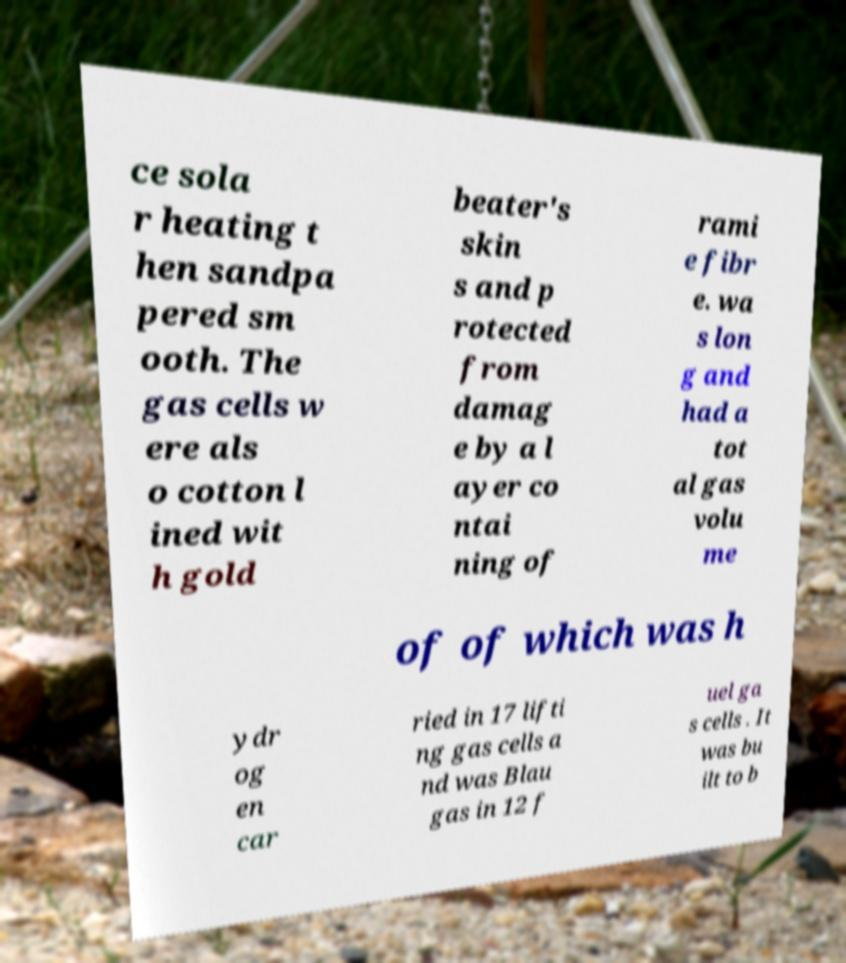I need the written content from this picture converted into text. Can you do that? ce sola r heating t hen sandpa pered sm ooth. The gas cells w ere als o cotton l ined wit h gold beater's skin s and p rotected from damag e by a l ayer co ntai ning of rami e fibr e. wa s lon g and had a tot al gas volu me of of which was h ydr og en car ried in 17 lifti ng gas cells a nd was Blau gas in 12 f uel ga s cells . It was bu ilt to b 